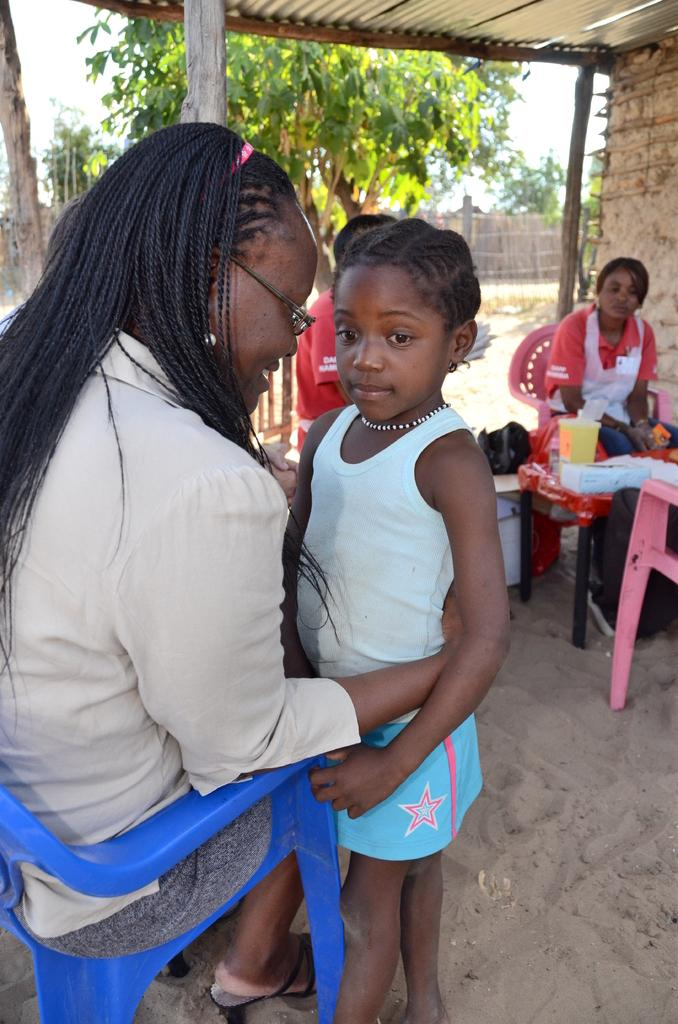What type of furniture is present in the image? There are chairs in the image. Who or what is present in the image along with the chairs? There are people in the image. What type of natural elements can be seen in the image? There are trees in the image. What is visible in the background of the image? The sky is visible in the image. Can you see any jellyfish swimming in the sky in the image? There are no jellyfish present in the image, and the sky is visible, not water where jellyfish would typically be found. 